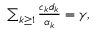<formula> <loc_0><loc_0><loc_500><loc_500>\begin{array} { r } { \sum _ { k \geq 1 } \frac { c _ { k } d _ { k } } { \alpha _ { k } } = \gamma , } \end{array}</formula> 